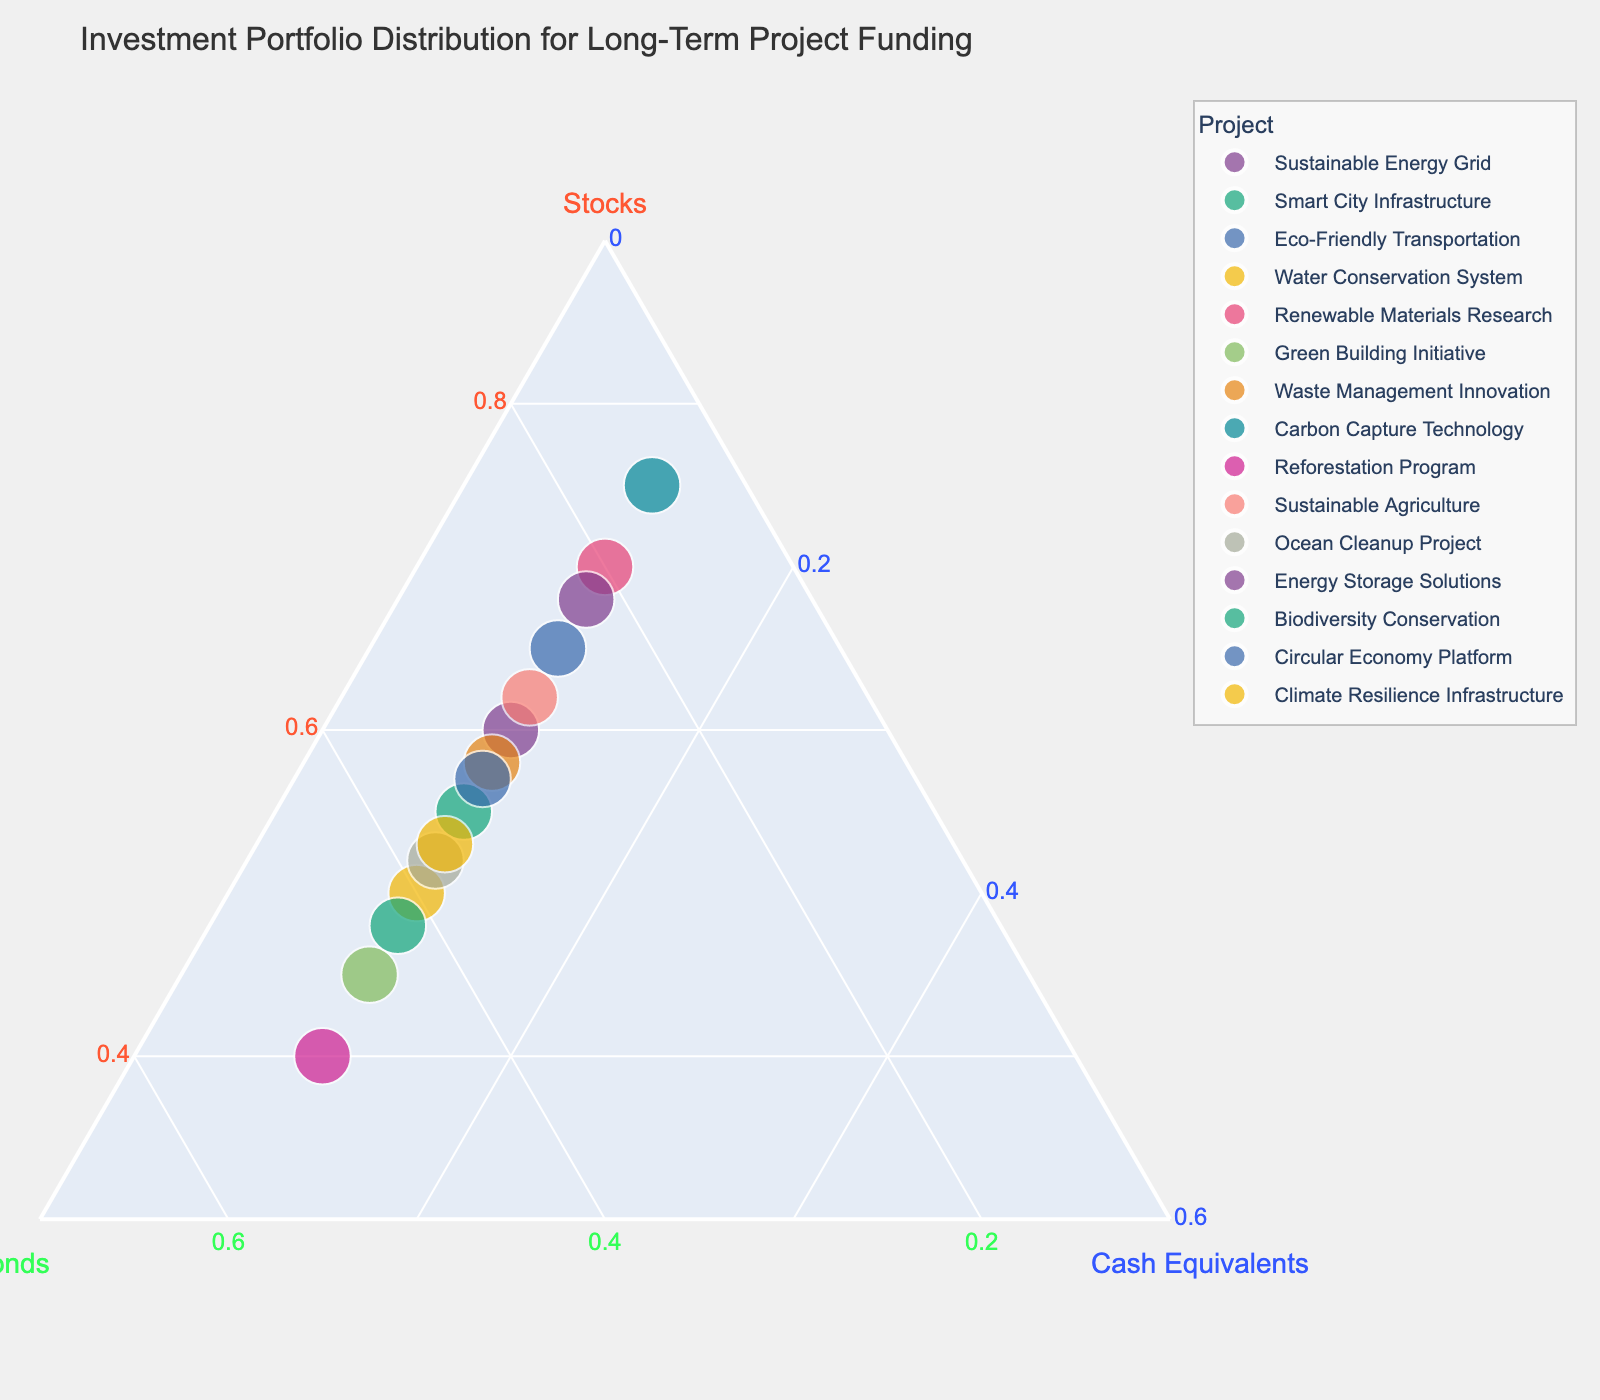What is the title of the plot? The title of the plot is typically displayed at the top of the figure. In this case, it is provided as "Investment Portfolio Distribution for Long-Term Project Funding."
Answer: Investment Portfolio Distribution for Long-Term Project Funding How many data points (projects) are shown in the plot? The plot displays data points for each project listed. By counting the projects in the dataset, we can see that there are 15 projects.
Answer: 15 What are the minimum values specified for the axes representing Stocks, Bonds, and Cash Equivalents? To determine the minimum values for each axis, we refer to the axis labels on the ternary plot. The axis for Stocks has a minimum of 0.3, Bonds 0.1, and Cash Equivalents 0.
Answer: Stocks: 0.3, Bonds: 0.1, Cash Equivalents: 0 Which project has the highest proportion of investments in stocks? To determine this, we look at the points closest to the Stocks vertex at the top of the ternary plot. From the data, "Carbon Capture Technology" has the highest stock proportion at 75%.
Answer: Carbon Capture Technology Which project has equal proportions of investments in stocks and bonds? We look for the project where the investments in stocks and bonds are the same. From the data, "Green Building Initiative" has 45% in both stocks and bonds.
Answer: Green Building Initiative What is the proportion of cash equivalents for all projects? All projects have the same proportion of Cash Equivalents, which is 10%. This can be seen from the consistent 10% value in the dataset for Cash Equivalents.
Answer: 10% Which project has the lowest proportion of investments in stocks? The project closest to the Bonds and Cash Equivalents vertex and away from the Stocks vertex will have the lowest proportion of investments in stocks. "Reforestation Program" has the lowest proportion in stocks at 40%.
Answer: Reforestation Program Of the listed projects, which one falls nearest to the center of the ternary plot? For a project to be closest to the center, the proportions of stocks, bonds, and cash equivalents should be more balanced. "Climate Resilience Infrastructure" with stocks at 53%, bonds at 37%, and cash equivalents at 10% appears closest to the center.
Answer: Climate Resilience Infrastructure What is the average proportion of investments in stocks across all projects? To find the average, sum the proportions of stocks for all projects and divide by the number of projects: (60+55+65+50+70+45+58+75+40+62+52+68+48+57+53) / 15 = 53.3%.
Answer: 53.3% Which three projects have the closest distribution of investments across stocks, bonds, and cash equivalents? Look for projects where stocks, bonds, and cash equivalents values are relatively balanced. "Green Building Initiative," "Climate Resilience Infrastructure," and "Smart City Infrastructure" each have closer distributions compared to others.
Answer: Green Building Initiative, Climate Resilience Infrastructure, Smart City Infrastructure 